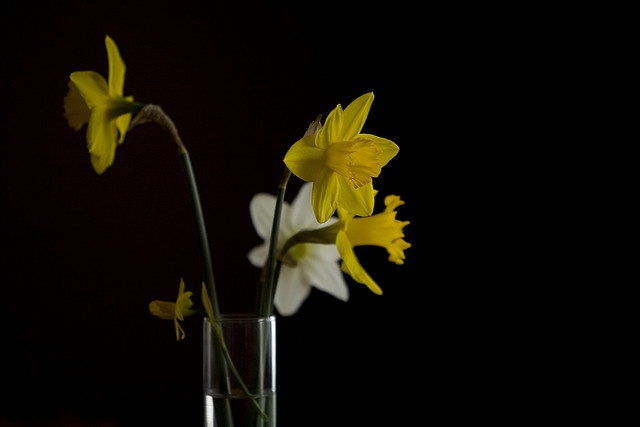Describe the objects in this image and their specific colors. I can see potted plant in black and olive tones and vase in black, gray, white, and darkgreen tones in this image. 